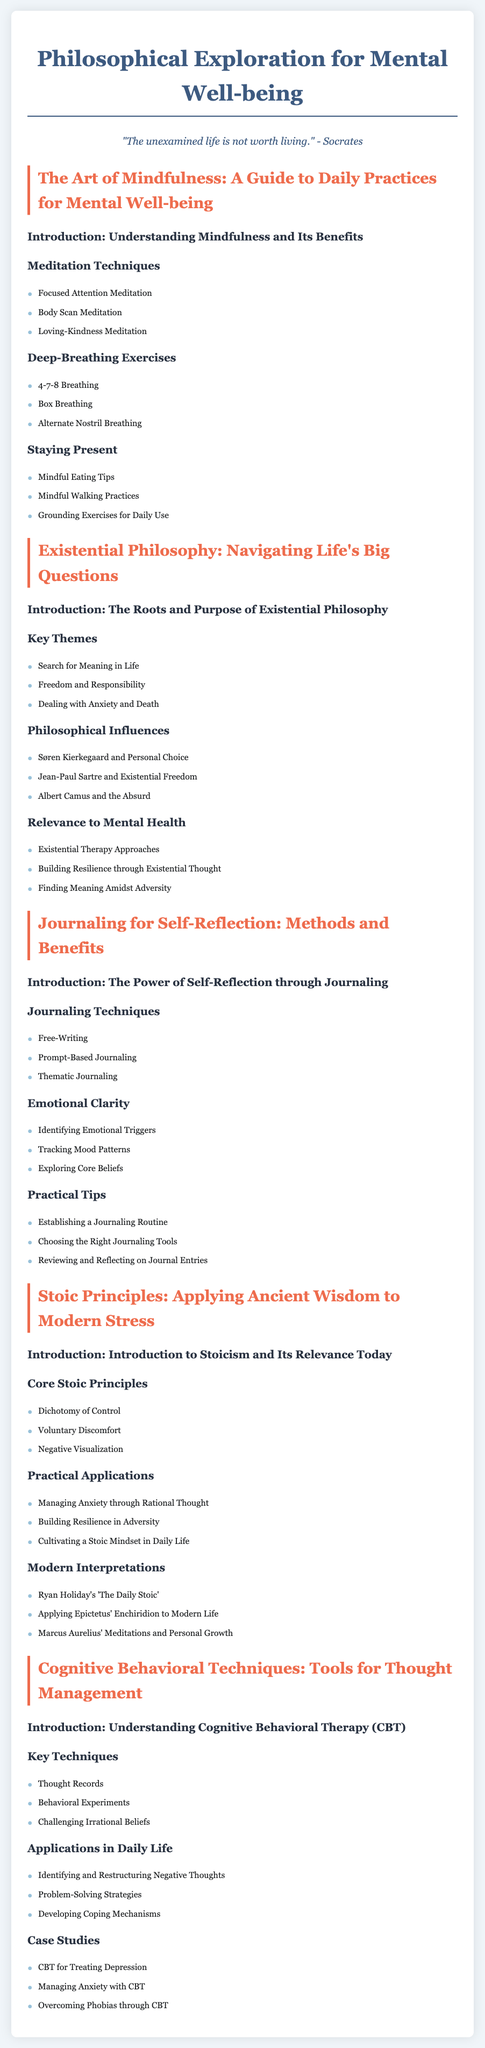What are the three meditation techniques listed? The document outlines three meditation techniques under the section on Meditation Techniques.
Answer: Focused Attention Meditation, Body Scan Meditation, Loving-Kindness Meditation What is the first technique under deep-breathing exercises? The first technique mentioned in the document for deep-breathing exercises.
Answer: 4-7-8 Breathing Name one key theme of existential philosophy. This information is found in the section addressing key themes of existential philosophy.
Answer: Search for Meaning in Life Which principle suggests focusing on what you can control? This principle is listed in the Stoic Principles section of the document.
Answer: Dichotomy of Control How many techniques are described under Cognitive Behavioral Techniques? The document enumerates the key techniques in the Cognitive Behavioral Techniques section.
Answer: Three 